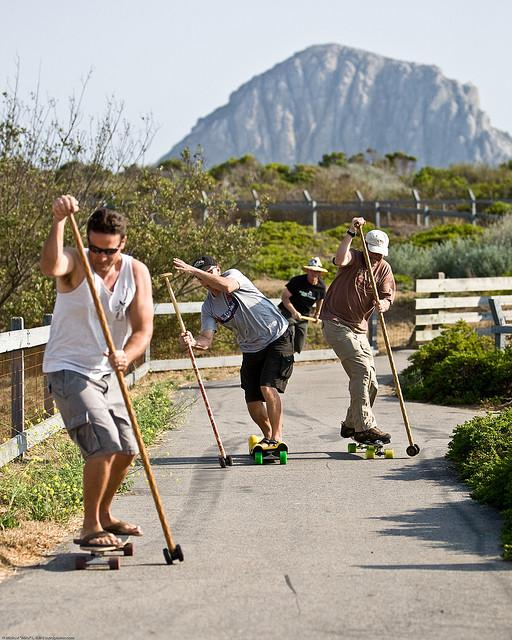What are the men doing with the large wooden poles? Please explain your reasoning. land paddling. They are using them to move themselves on the skateboards 